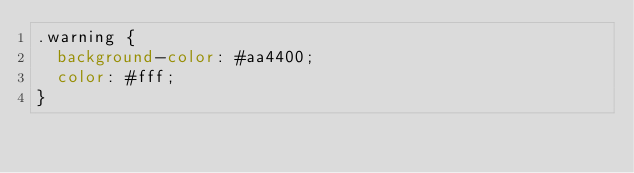<code> <loc_0><loc_0><loc_500><loc_500><_CSS_>.warning {
  background-color: #aa4400;
  color: #fff;
}
</code> 